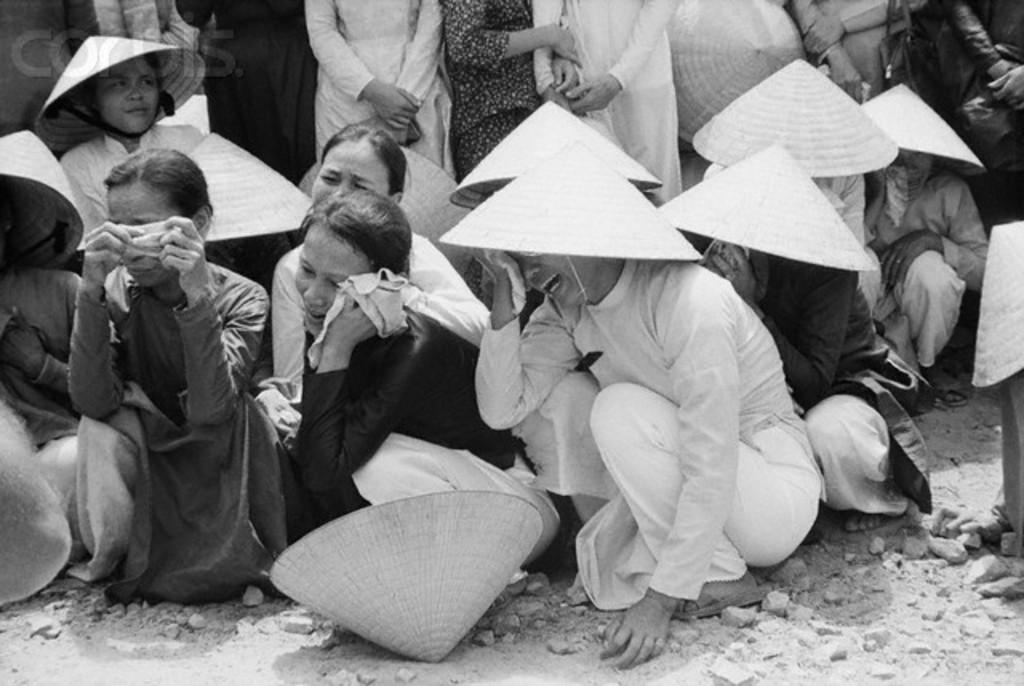What is the color scheme of the image? The image is black and white. What are the people in the image doing? The people are sitting on the ground and crying. What are the people wearing on their heads? The people are wearing hats. What can be seen at the bottom of the image? There are stones at the bottom of the image. Where is the washbasin located in the image? There is no washbasin present in the image. What type of hammer is being used by the people in the image? There are no hammers present in the image; the people are wearing hats and crying. 